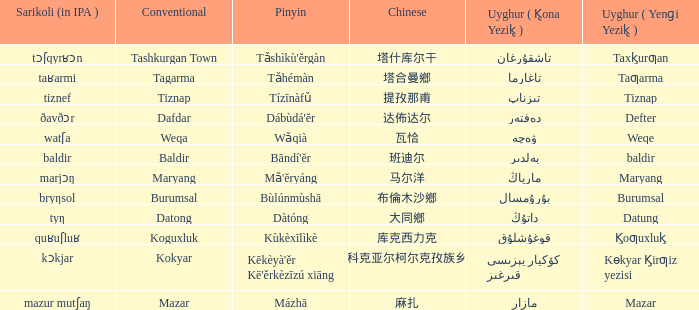Identify the conventional approach used for keeping a defter. Dafdar. 